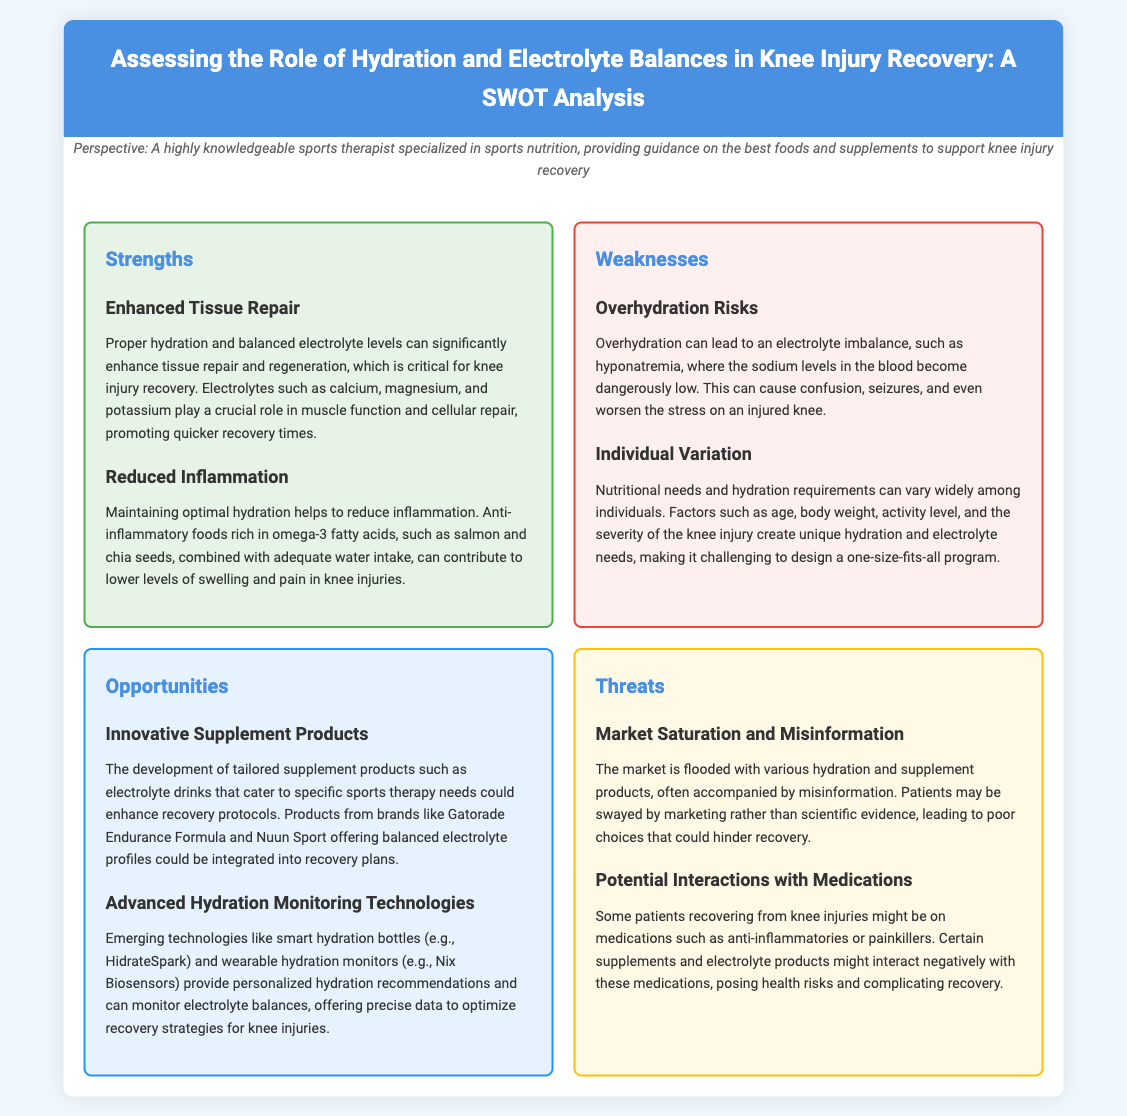What is the main title of the document? The main title summarizes the document's focus, which is on hydration and electrolyte balances in knee injury recovery.
Answer: Assessing the Role of Hydration and Electrolyte Balances in Knee Injury Recovery: A SWOT Analysis What are two key strengths mentioned? The strengths outlined include important aspects of hydration and electrolytes that benefit knee injury recovery.
Answer: Enhanced Tissue Repair, Reduced Inflammation What is one potential risk of overhydration? The document identifies specific risk factors associated with overhydration, particularly its impact on electrolyte levels.
Answer: Hyponatremia Name one opportunity for recovery improvement. Opportunities in the document highlight potential advancements in hydration and supplementation that could enhance recovery methods.
Answer: Innovative Supplement Products What specific technology is mentioned for hydration monitoring? The document lists modern technological solutions aimed at improving hydration tracking for recovery purposes.
Answer: HidrateSpark Which market issue is noted as a threat? The threats discussed in the document address challenges related to product quality and misinformation.
Answer: Market Saturation and Misinformation What element is critical for muscle function as per strengths? The document outlines essential elements that contribute to recovery, especially in relation to muscle functionality.
Answer: Electrolytes Which patient group might face potential medication interactions? The document warns about interactions specifically concerning individuals undergoing treatment for knee injuries.
Answer: Patients recovering from knee injuries 